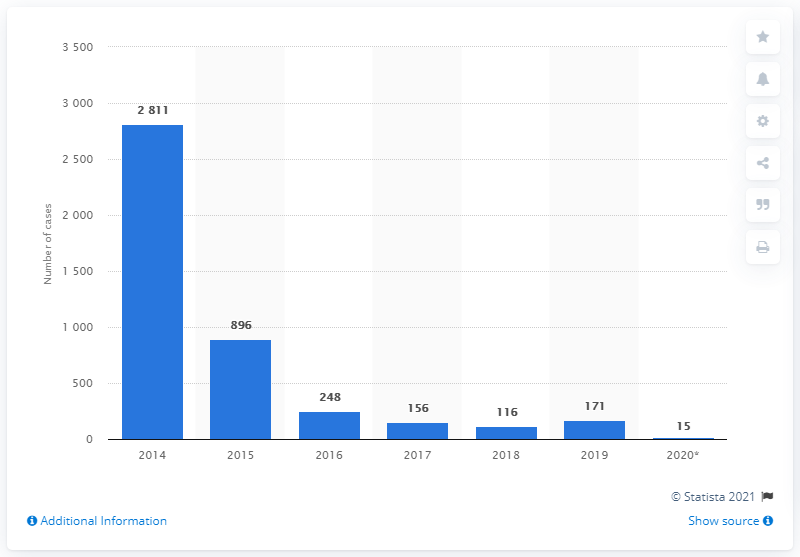Mention a couple of crucial points in this snapshot. In 2019, there were 171 reported cases of chikungunya virus. 